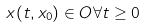<formula> <loc_0><loc_0><loc_500><loc_500>x ( t , x _ { 0 } ) \in O \forall t \geq 0</formula> 